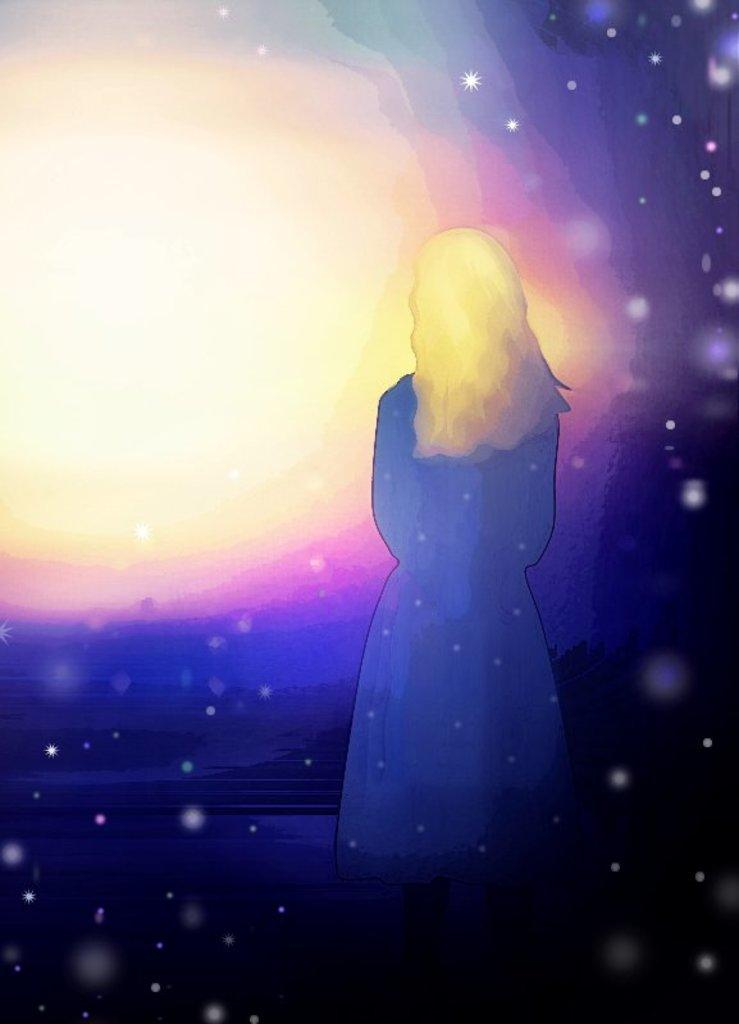What type of image is being described? The image is graphical in nature. Can you describe the main subject of the image? There is a person in the center of the image. What else can be seen in the background of the image? There are lights visible in the background of the image. How many snakes are wrapped around the person in the image? There are no snakes present in the image; it features a person in the center with lights in the background. What type of cub is playing with the person in the image? There is no cub present in the image; it only features a person and lights in the background. 